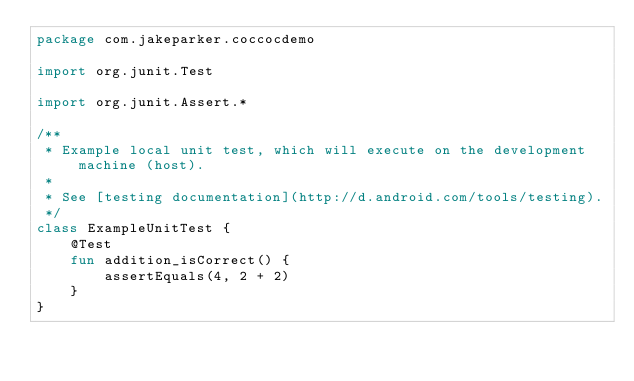<code> <loc_0><loc_0><loc_500><loc_500><_Kotlin_>package com.jakeparker.coccocdemo

import org.junit.Test

import org.junit.Assert.*

/**
 * Example local unit test, which will execute on the development machine (host).
 *
 * See [testing documentation](http://d.android.com/tools/testing).
 */
class ExampleUnitTest {
    @Test
    fun addition_isCorrect() {
        assertEquals(4, 2 + 2)
    }
}</code> 